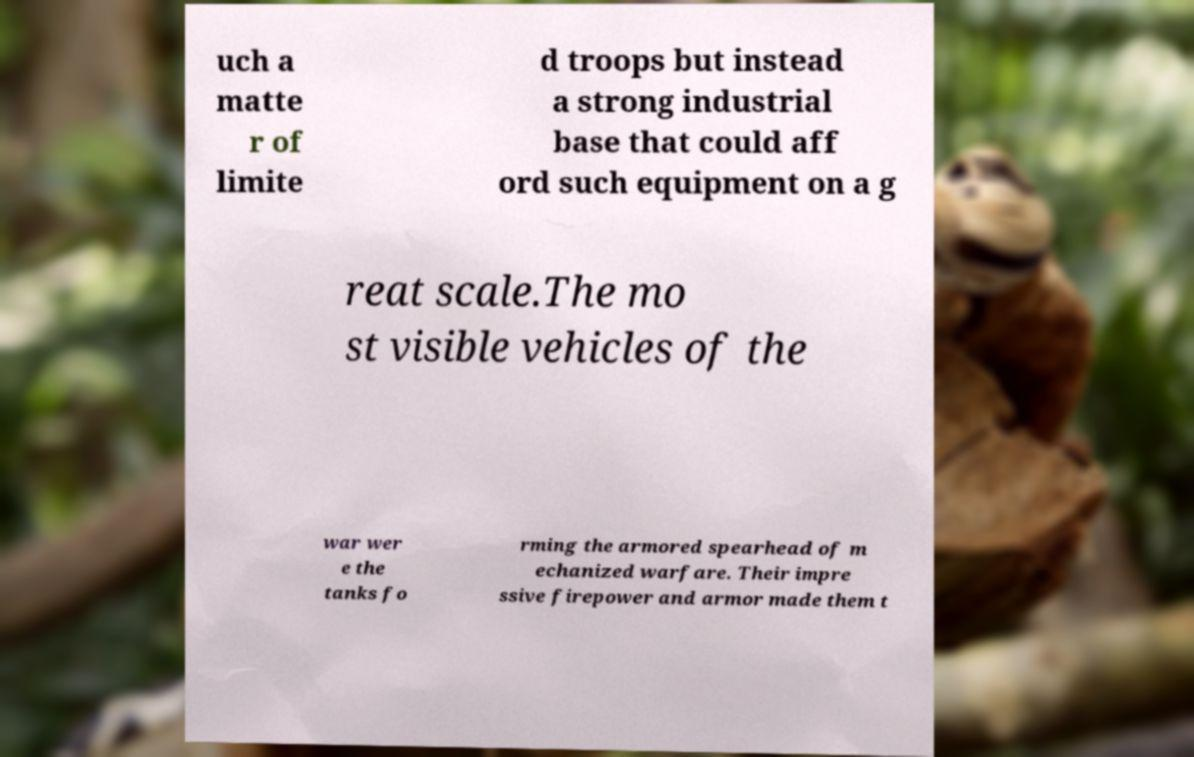There's text embedded in this image that I need extracted. Can you transcribe it verbatim? uch a matte r of limite d troops but instead a strong industrial base that could aff ord such equipment on a g reat scale.The mo st visible vehicles of the war wer e the tanks fo rming the armored spearhead of m echanized warfare. Their impre ssive firepower and armor made them t 